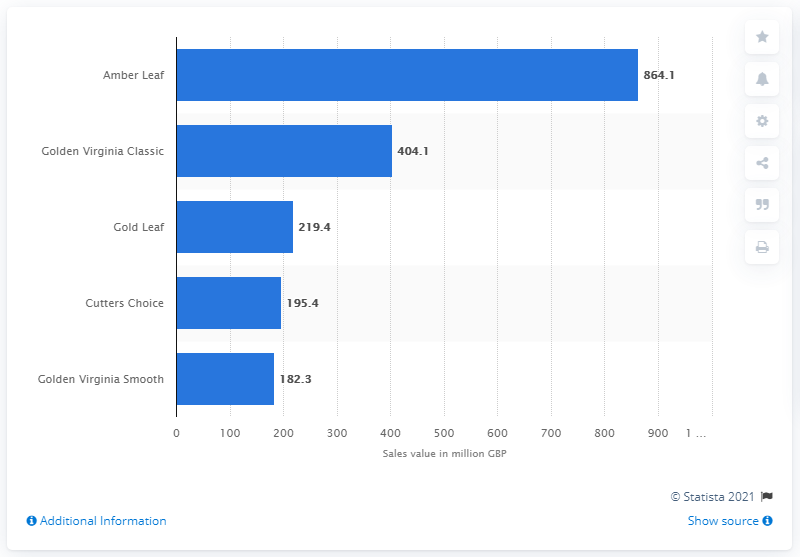Give some essential details in this illustration. In 2016, the highest selling hand-rolled tobacco brand in the UK was Amber Leaf. In 2016, Amber Leaf's sales in British pounds were 864.1. 